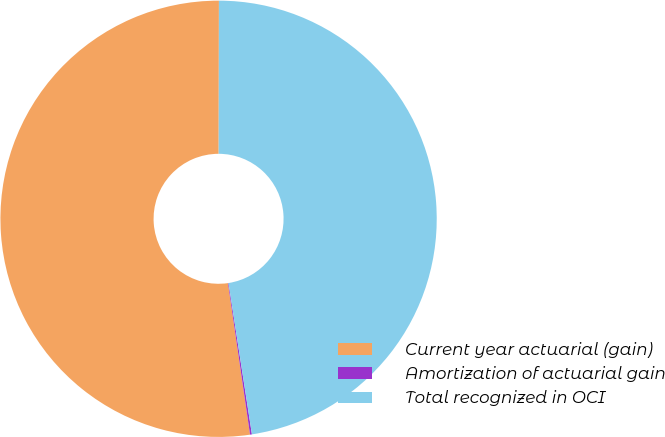Convert chart. <chart><loc_0><loc_0><loc_500><loc_500><pie_chart><fcel>Current year actuarial (gain)<fcel>Amortization of actuarial gain<fcel>Total recognized in OCI<nl><fcel>52.33%<fcel>0.14%<fcel>47.53%<nl></chart> 